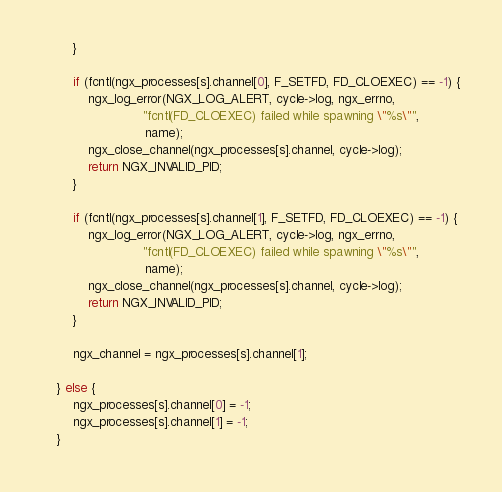<code> <loc_0><loc_0><loc_500><loc_500><_C_>        }

        if (fcntl(ngx_processes[s].channel[0], F_SETFD, FD_CLOEXEC) == -1) {
            ngx_log_error(NGX_LOG_ALERT, cycle->log, ngx_errno,
                          "fcntl(FD_CLOEXEC) failed while spawning \"%s\"",
                           name);
            ngx_close_channel(ngx_processes[s].channel, cycle->log);
            return NGX_INVALID_PID;
        }

        if (fcntl(ngx_processes[s].channel[1], F_SETFD, FD_CLOEXEC) == -1) {
            ngx_log_error(NGX_LOG_ALERT, cycle->log, ngx_errno,
                          "fcntl(FD_CLOEXEC) failed while spawning \"%s\"",
                           name);
            ngx_close_channel(ngx_processes[s].channel, cycle->log);
            return NGX_INVALID_PID;
        }

        ngx_channel = ngx_processes[s].channel[1];

    } else {
        ngx_processes[s].channel[0] = -1;
        ngx_processes[s].channel[1] = -1;
    }
</code> 